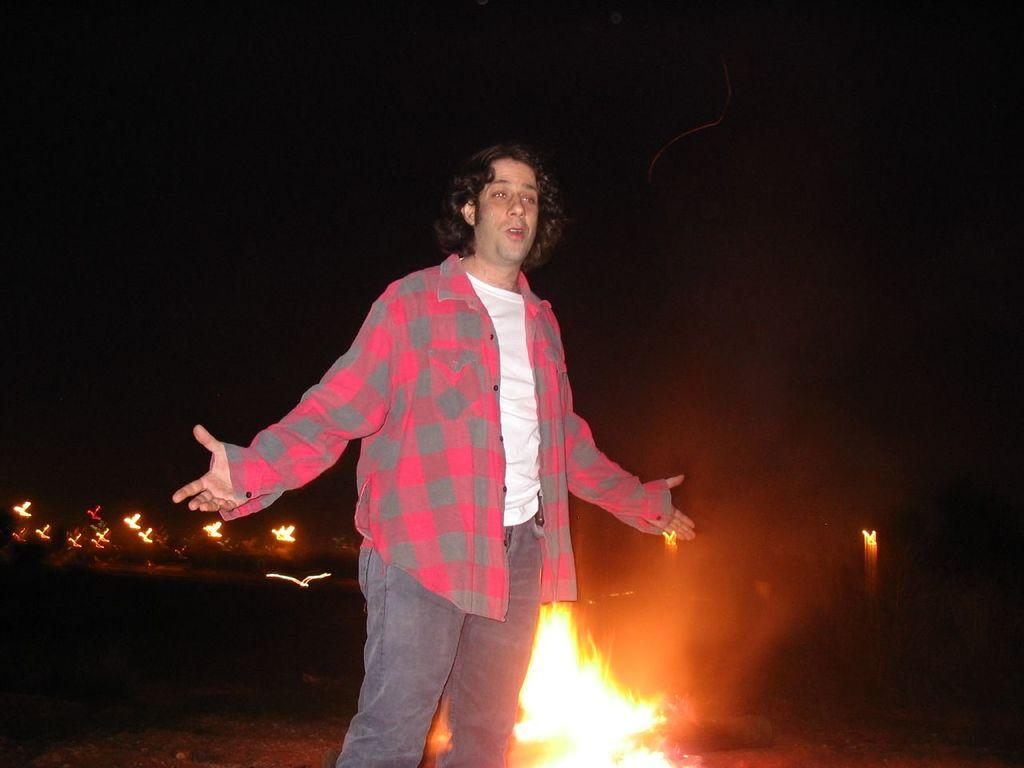What is the main subject of the image? The main subject of the image is a man standing. What is the secondary subject in the image? There is fire in the image. What is the color of the background in the image? The background of the image is black. What type of comparison can be made between the man and the clover in the image? There is no clover present in the image, so no comparison can be made. What type of writing instrument is the writer using in the image? There is no writer or writing instrument present in the image. 